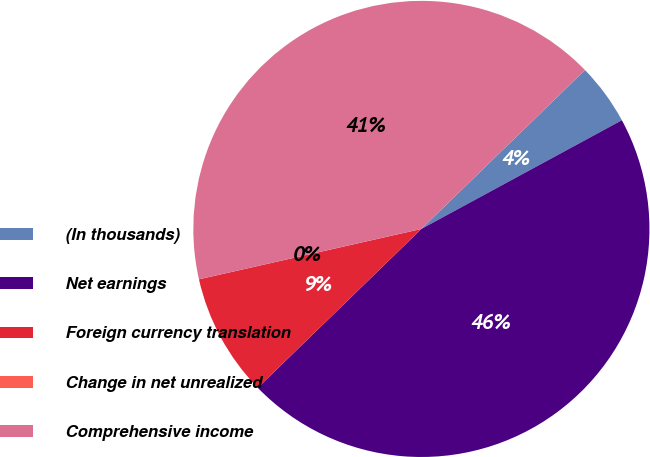Convert chart to OTSL. <chart><loc_0><loc_0><loc_500><loc_500><pie_chart><fcel>(In thousands)<fcel>Net earnings<fcel>Foreign currency translation<fcel>Change in net unrealized<fcel>Comprehensive income<nl><fcel>4.36%<fcel>45.64%<fcel>8.72%<fcel>0.0%<fcel>41.28%<nl></chart> 